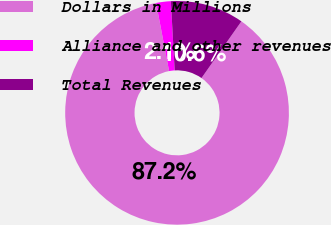Convert chart to OTSL. <chart><loc_0><loc_0><loc_500><loc_500><pie_chart><fcel>Dollars in Millions<fcel>Alliance and other revenues<fcel>Total Revenues<nl><fcel>87.24%<fcel>2.12%<fcel>10.64%<nl></chart> 